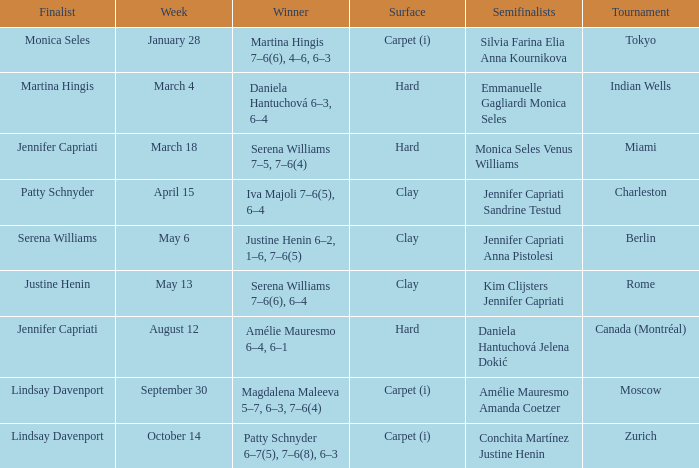Who was the winner in the Indian Wells? Daniela Hantuchová 6–3, 6–4. 